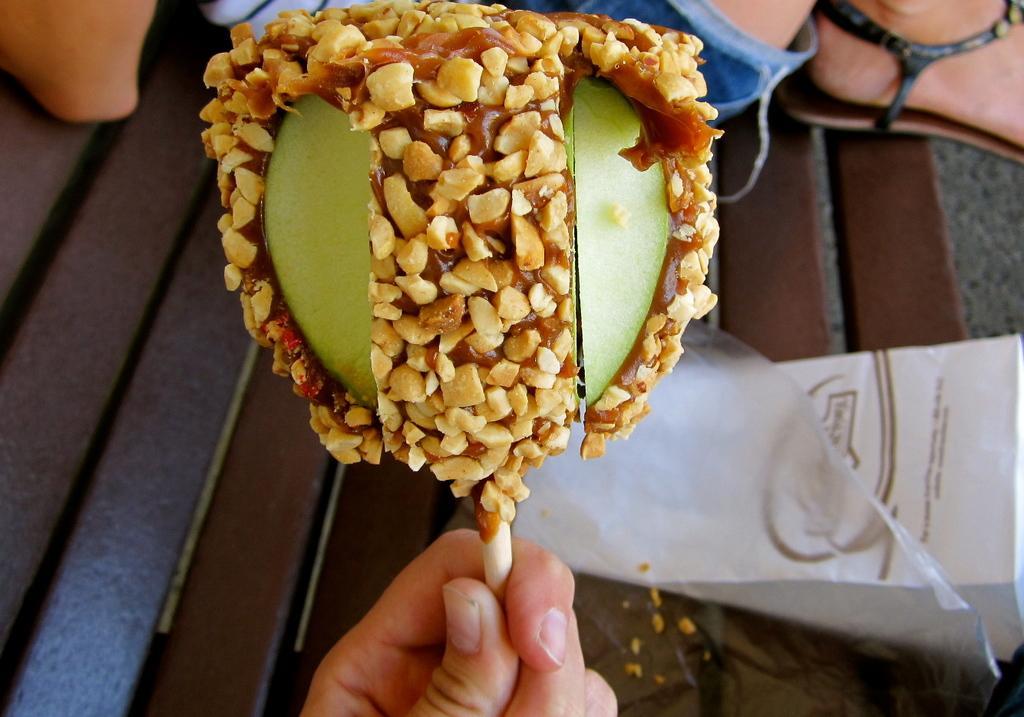How would you summarize this image in a sentence or two? In the foreground of this picture, there is a person's hand holding a candy in their hand and in the background, there are covers, and a person sitting on the bench. 